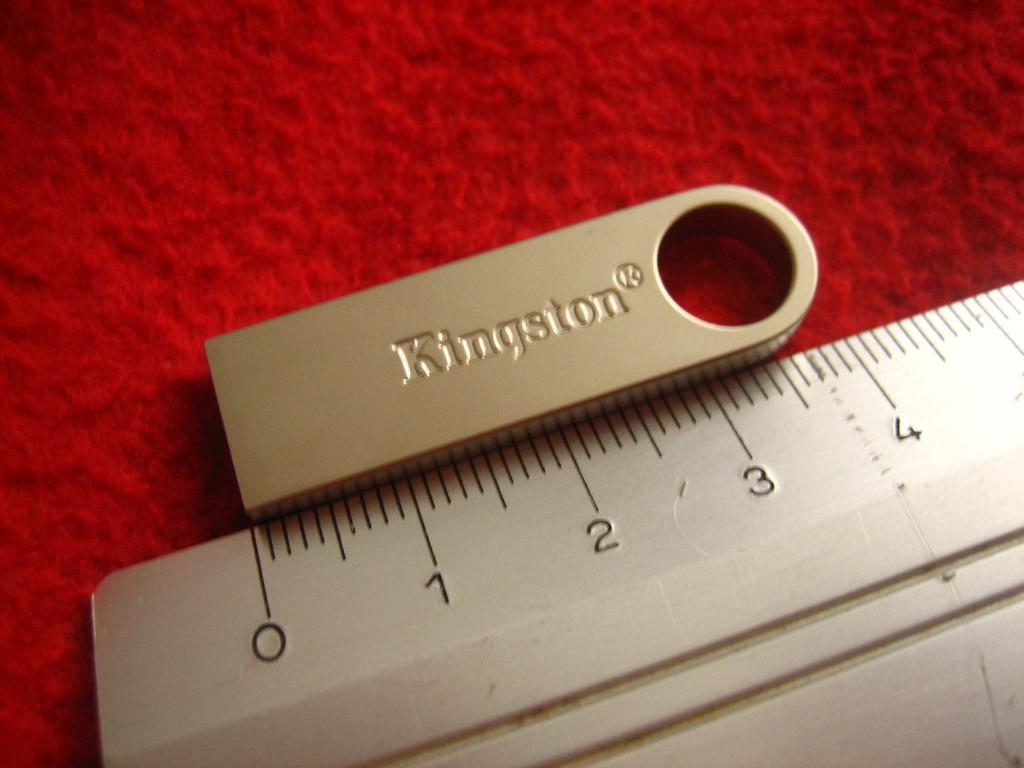What number is on the far left?
Provide a succinct answer. 0. What company name is printed on the usb drive?
Offer a very short reply. Kingston. 